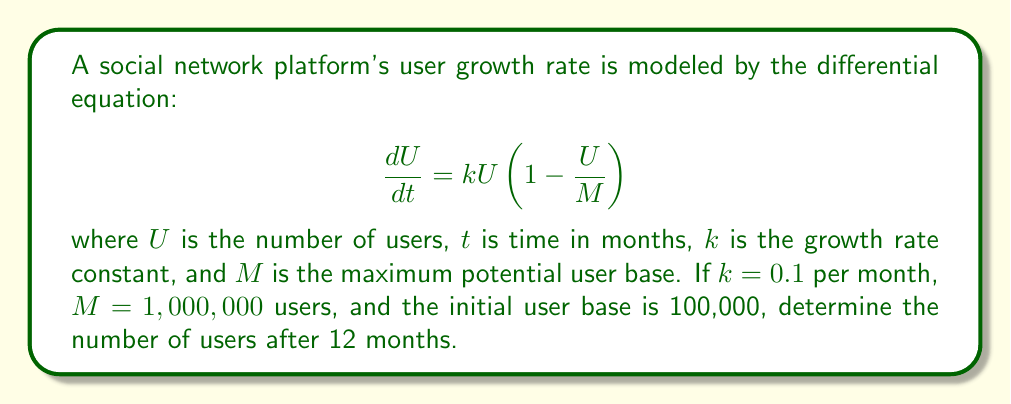Teach me how to tackle this problem. To solve this problem, we need to use the logistic growth model, which is a first-order differential equation. Let's approach this step-by-step:

1) The given differential equation is:

   $$ \frac{dU}{dt} = kU(1 - \frac{U}{M}) $$

2) We're given the following values:
   $k = 0.1$ per month
   $M = 1,000,000$ users
   Initial user base $U(0) = 100,000$ users

3) The solution to this logistic growth equation is:

   $$ U(t) = \frac{M}{1 + (\frac{M}{U_0} - 1)e^{-kt}} $$

   where $U_0$ is the initial number of users.

4) Let's substitute our known values:

   $$ U(t) = \frac{1,000,000}{1 + (\frac{1,000,000}{100,000} - 1)e^{-0.1t}} $$

5) Simplify:

   $$ U(t) = \frac{1,000,000}{1 + 9e^{-0.1t}} $$

6) Now, we want to find $U(12)$, so let's substitute $t = 12$:

   $$ U(12) = \frac{1,000,000}{1 + 9e^{-0.1(12)}} $$

7) Calculate:

   $$ U(12) = \frac{1,000,000}{1 + 9e^{-1.2}} $$
   $$ U(12) = \frac{1,000,000}{1 + 9(0.301194)} $$
   $$ U(12) = \frac{1,000,000}{3.710746} $$
   $$ U(12) = 269,487.7 $$

8) Rounding to the nearest whole number (as we can't have fractional users):

   $$ U(12) \approx 269,488 \text{ users} $$
Answer: After 12 months, the social network platform will have approximately 269,488 users. 